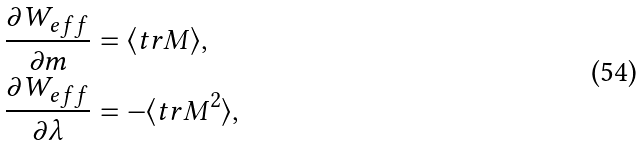<formula> <loc_0><loc_0><loc_500><loc_500>\frac { \partial W _ { e f f } } { \partial m } & = \langle t r M \rangle , \\ \frac { \partial W _ { e f f } } { \partial \lambda } & = - \langle t r M ^ { 2 } \rangle ,</formula> 